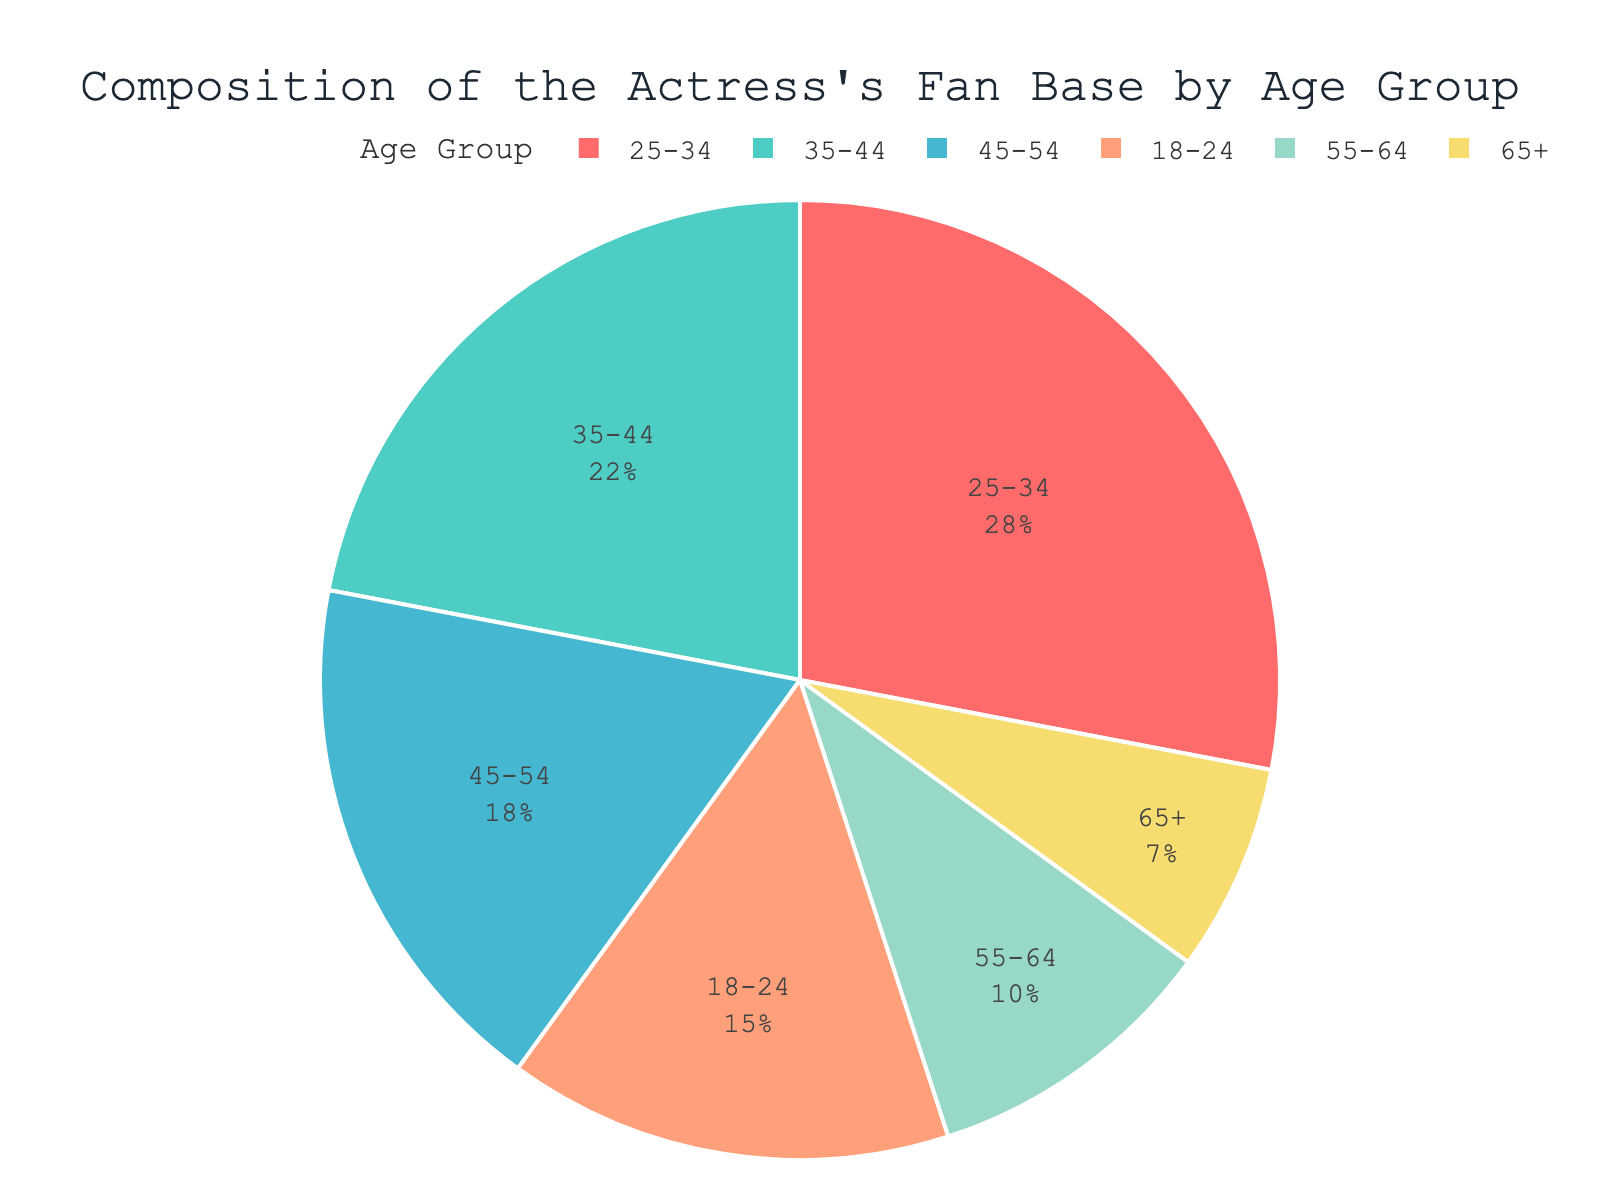What's the largest age group in the actress's fan base? The figure shows that the 25-34 age group has the highest percentage.
Answer: 25-34 Which age group has the smallest fan base percentage? The 65+ age group has the smallest portion in the pie chart.
Answer: 65+ What's the combined percentage of fans aged 35-54? Sum the percentages of the 35-44 and 45-54 age groups: 22 + 18 = 40%.
Answer: 40% Is the percentage of fans aged 18-24 greater than those aged 55-64? The chart shows 18-24 has 15% and 55-64 has 10%; 15% is greater than 10%.
Answer: Yes What is the difference in percentage between the largest and smallest age groups? Subtract the smallest percentage (7% for 65+) from the largest (28% for 25-34): 28 - 7 = 21%.
Answer: 21% How many age groups have a fan base percentage of 20% or more? The 25-34 and 35-44 age groups both have percentages over 20%, totaling 2 groups.
Answer: 2 What's the total percentage for fans aged 45 and above? Sum the percentages for the 45-54, 55-64, and 65+ age groups: 18 + 10 + 7 = 35%.
Answer: 35% Which age group is represented with the color closest to blue? The age group 35-44 is shown in a color closest to blue.
Answer: 35-44 